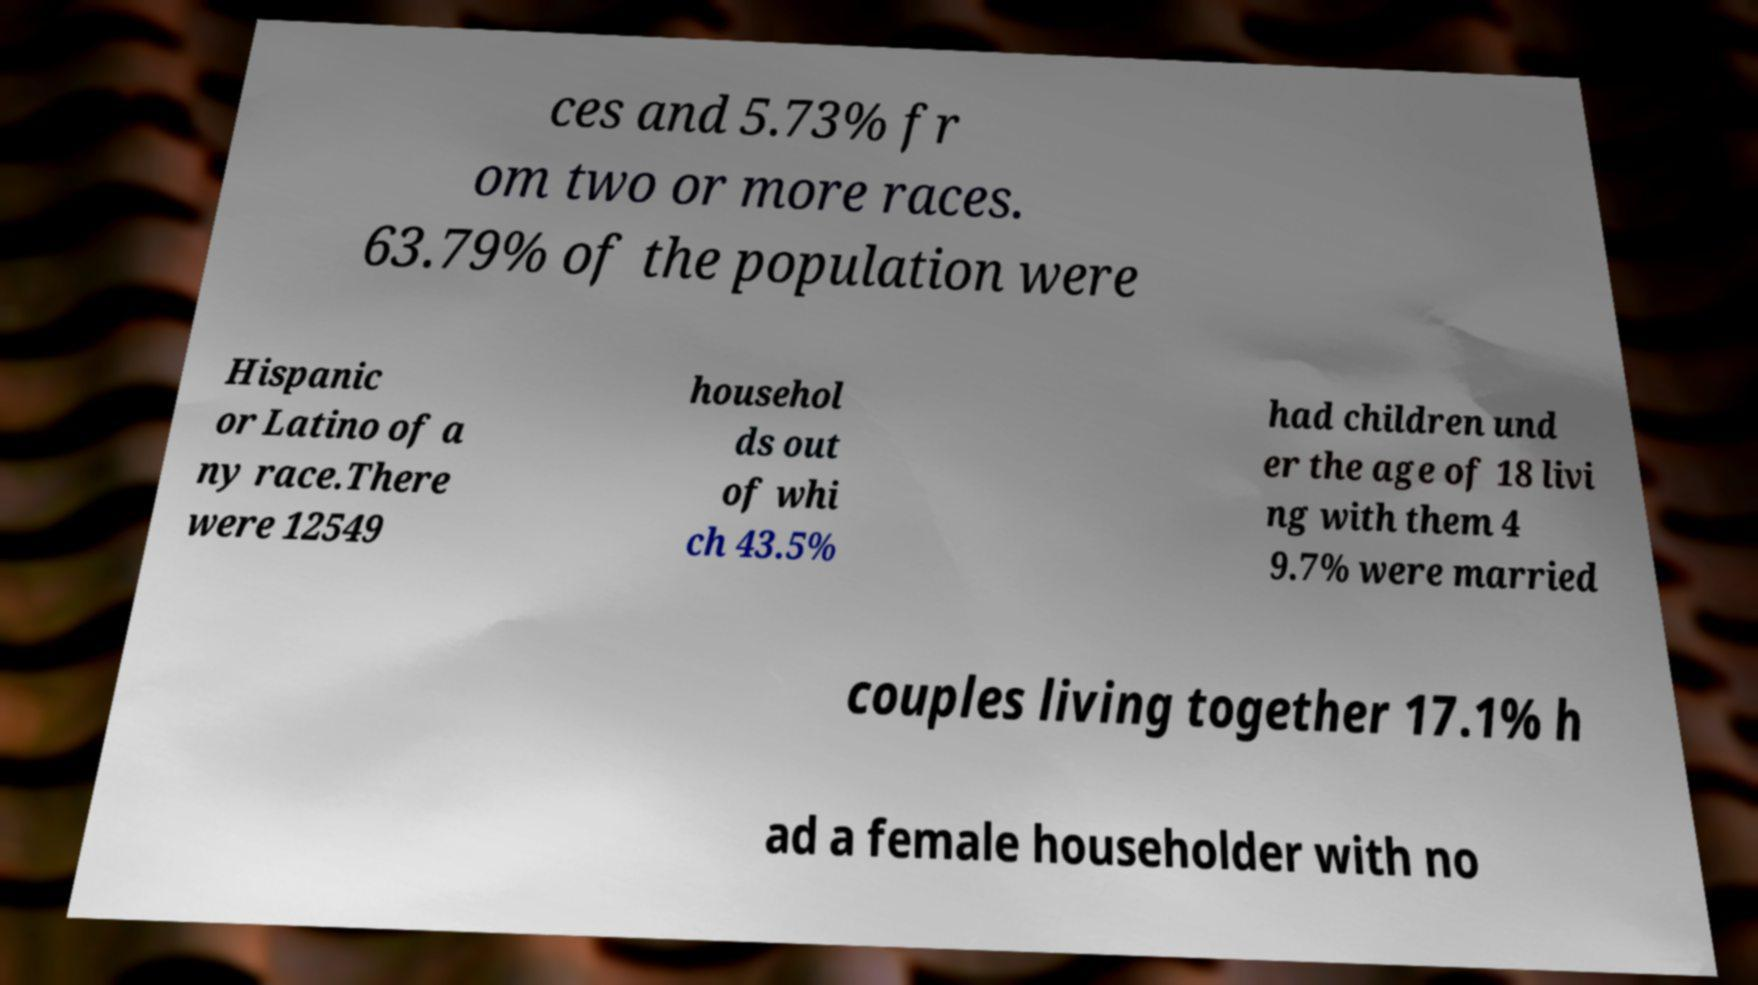Could you assist in decoding the text presented in this image and type it out clearly? ces and 5.73% fr om two or more races. 63.79% of the population were Hispanic or Latino of a ny race.There were 12549 househol ds out of whi ch 43.5% had children und er the age of 18 livi ng with them 4 9.7% were married couples living together 17.1% h ad a female householder with no 